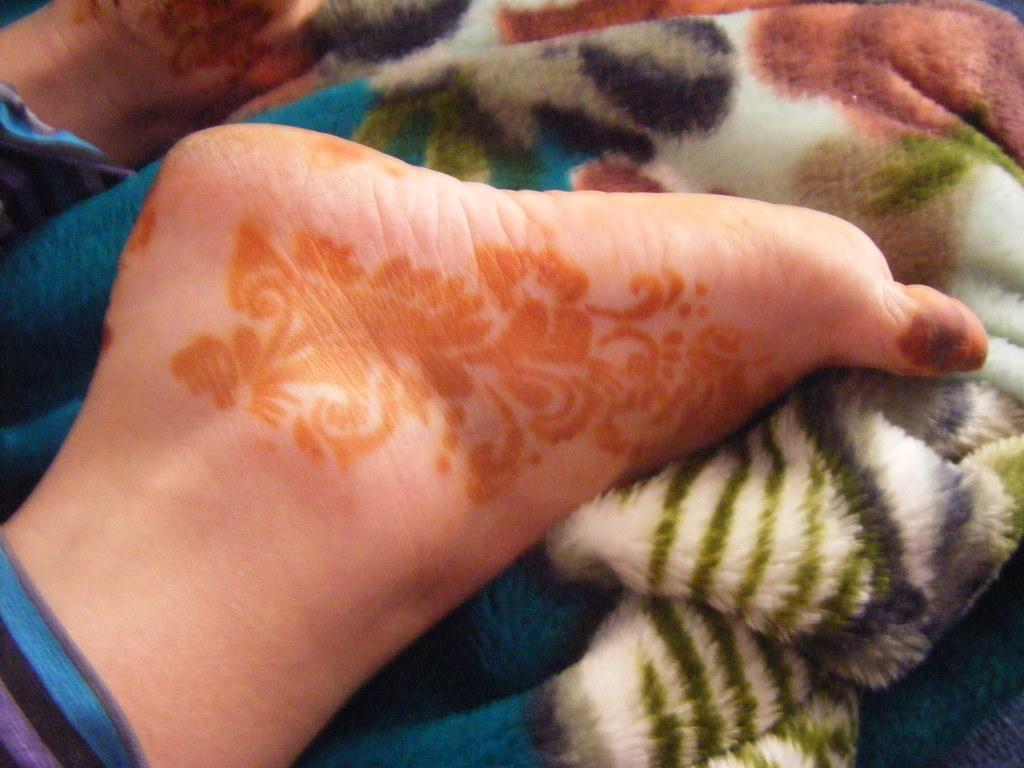Please provide a concise description of this image. In this image we can see a person legs and a blanket. 